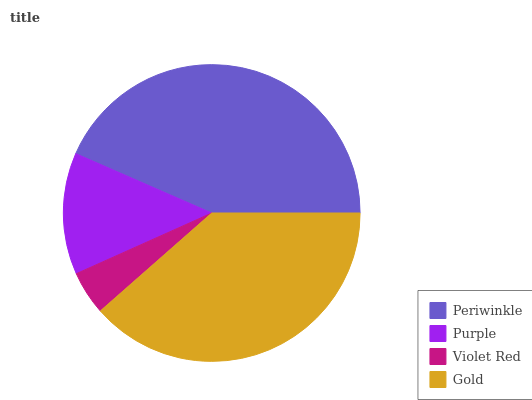Is Violet Red the minimum?
Answer yes or no. Yes. Is Periwinkle the maximum?
Answer yes or no. Yes. Is Purple the minimum?
Answer yes or no. No. Is Purple the maximum?
Answer yes or no. No. Is Periwinkle greater than Purple?
Answer yes or no. Yes. Is Purple less than Periwinkle?
Answer yes or no. Yes. Is Purple greater than Periwinkle?
Answer yes or no. No. Is Periwinkle less than Purple?
Answer yes or no. No. Is Gold the high median?
Answer yes or no. Yes. Is Purple the low median?
Answer yes or no. Yes. Is Periwinkle the high median?
Answer yes or no. No. Is Periwinkle the low median?
Answer yes or no. No. 